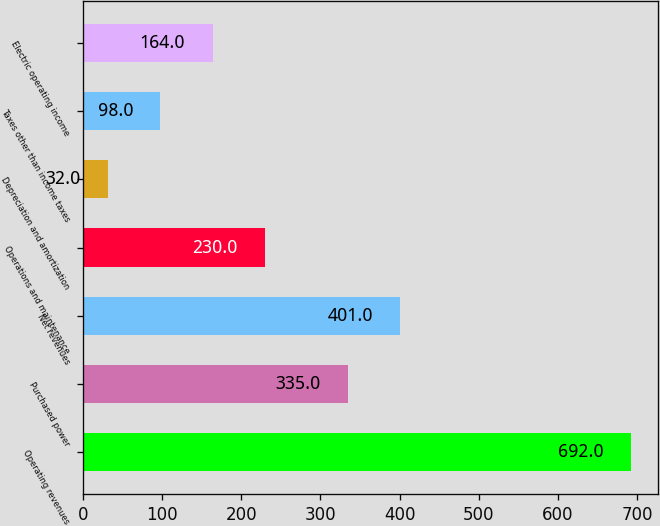Convert chart to OTSL. <chart><loc_0><loc_0><loc_500><loc_500><bar_chart><fcel>Operating revenues<fcel>Purchased power<fcel>Net revenues<fcel>Operations and maintenance<fcel>Depreciation and amortization<fcel>Taxes other than income taxes<fcel>Electric operating income<nl><fcel>692<fcel>335<fcel>401<fcel>230<fcel>32<fcel>98<fcel>164<nl></chart> 